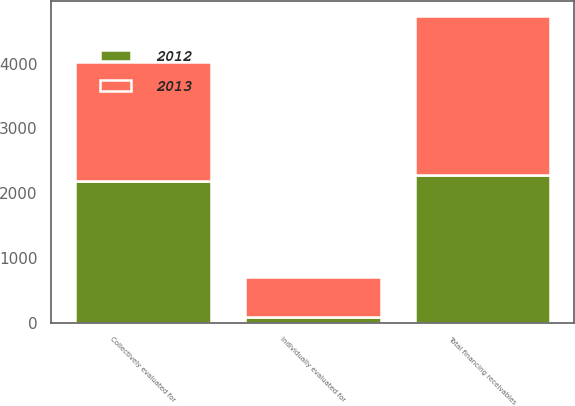<chart> <loc_0><loc_0><loc_500><loc_500><stacked_bar_chart><ecel><fcel>Individually evaluated for<fcel>Collectively evaluated for<fcel>Total financing receivables<nl><fcel>2012<fcel>95<fcel>2191<fcel>2286<nl><fcel>2013<fcel>616<fcel>1826<fcel>2442<nl></chart> 